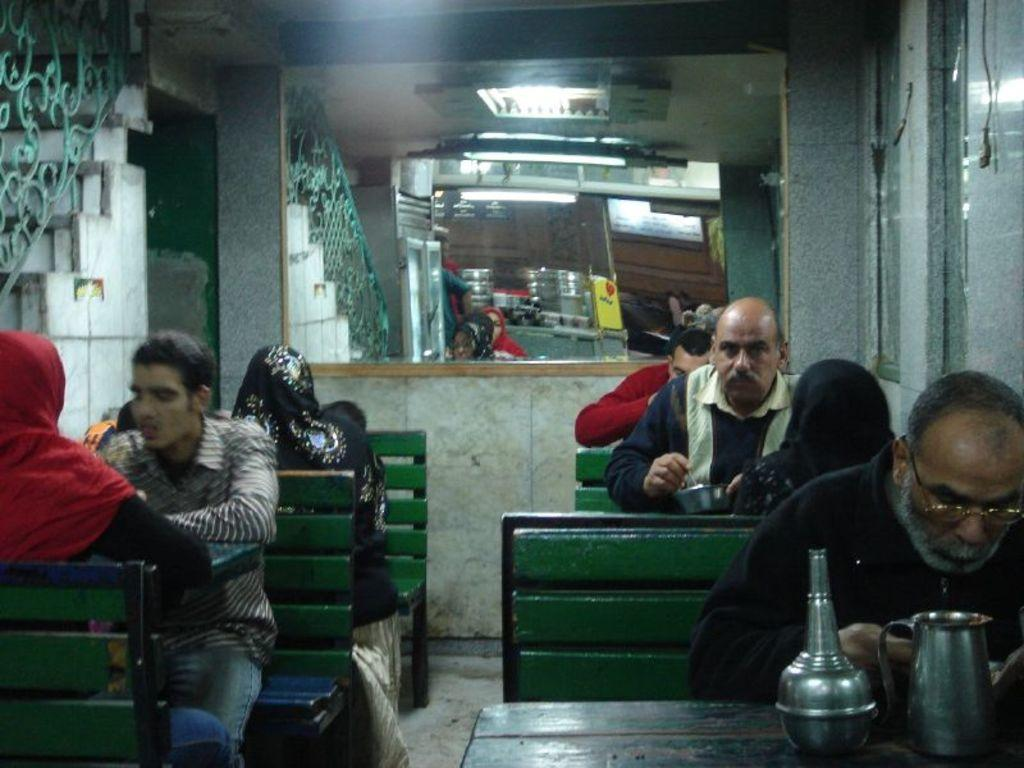What are the people in the image doing? The people in the image are sitting on benches. What other objects can be seen in the image besides the benches? There are tables in the image, and a jug is on one of the tables. Can you describe any other features in the image? Yes, there is a mirror in the image. What type of paste is being used by the people sitting on the benches in the image? There is no paste present in the image, and the people sitting on the benches are not using any paste. 